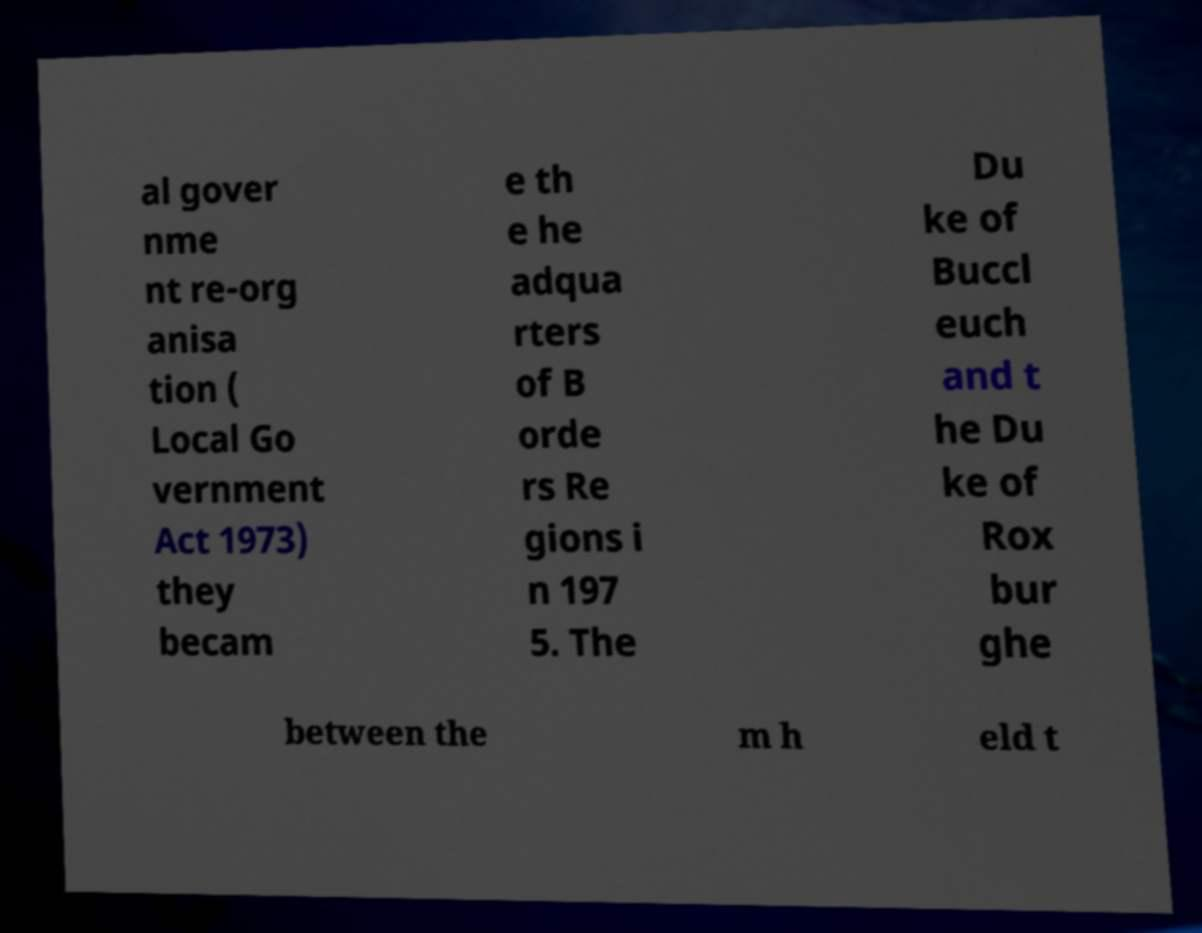Could you extract and type out the text from this image? al gover nme nt re-org anisa tion ( Local Go vernment Act 1973) they becam e th e he adqua rters of B orde rs Re gions i n 197 5. The Du ke of Buccl euch and t he Du ke of Rox bur ghe between the m h eld t 